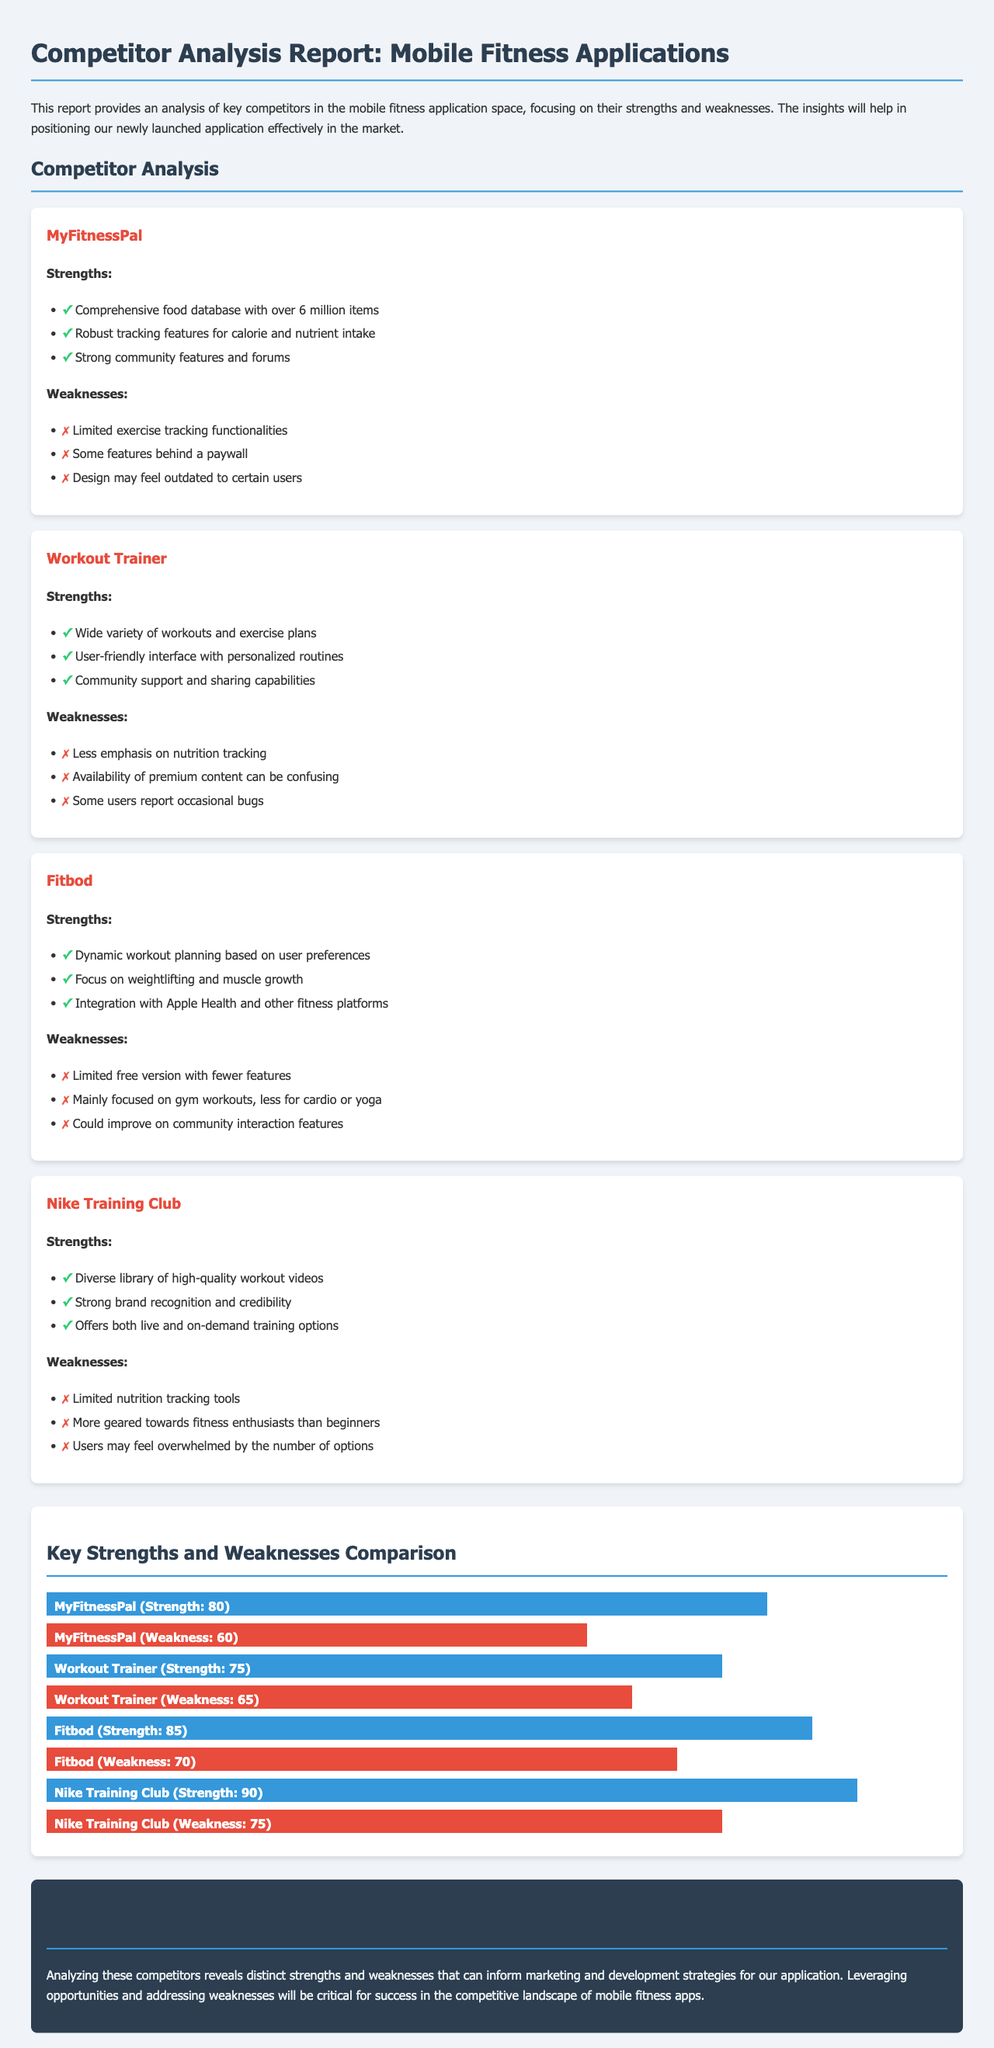What is the title of the report? The title of the report is located at the beginning of the document and is clearly stated as "Competitor Analysis Report: Mobile Fitness Applications."
Answer: Competitor Analysis Report: Mobile Fitness Applications How many strengths are listed for MyFitnessPal? The document outlines three strengths for MyFitnessPal listed under the strengths section.
Answer: 3 Which application has the highest strength rating? The strength ratings are visually represented in the chart, identifying Nike Training Club with a strength rating of 90 as the highest.
Answer: Nike Training Club What is a noted weakness of Workout Trainer? The document specifies that one of the weaknesses of Workout Trainer is "Less emphasis on nutrition tracking."
Answer: Less emphasis on nutrition tracking How many weaknesses are listed for Fitbod? The document enumerates three weaknesses for Fitbod detailed under the weaknesses section.
Answer: 3 Which competitor has the strongest community features? MyFitnessPal is highlighted for its robust community features and forums under its strengths section.
Answer: MyFitnessPal What does the conclusion suggest for marketing strategies? The conclusion emphasizes leveraging opportunities and addressing weaknesses as critical strategies for success.
Answer: Leveraging opportunities and addressing weaknesses What percentage of strength does Fitbod have? The chart shows Fitbod with a strength rating of 85%.
Answer: 85% 